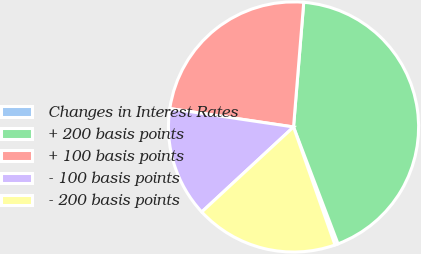Convert chart to OTSL. <chart><loc_0><loc_0><loc_500><loc_500><pie_chart><fcel>Changes in Interest Rates<fcel>+ 200 basis points<fcel>+ 100 basis points<fcel>- 100 basis points<fcel>- 200 basis points<nl><fcel>0.41%<fcel>42.91%<fcel>23.95%<fcel>14.24%<fcel>18.49%<nl></chart> 